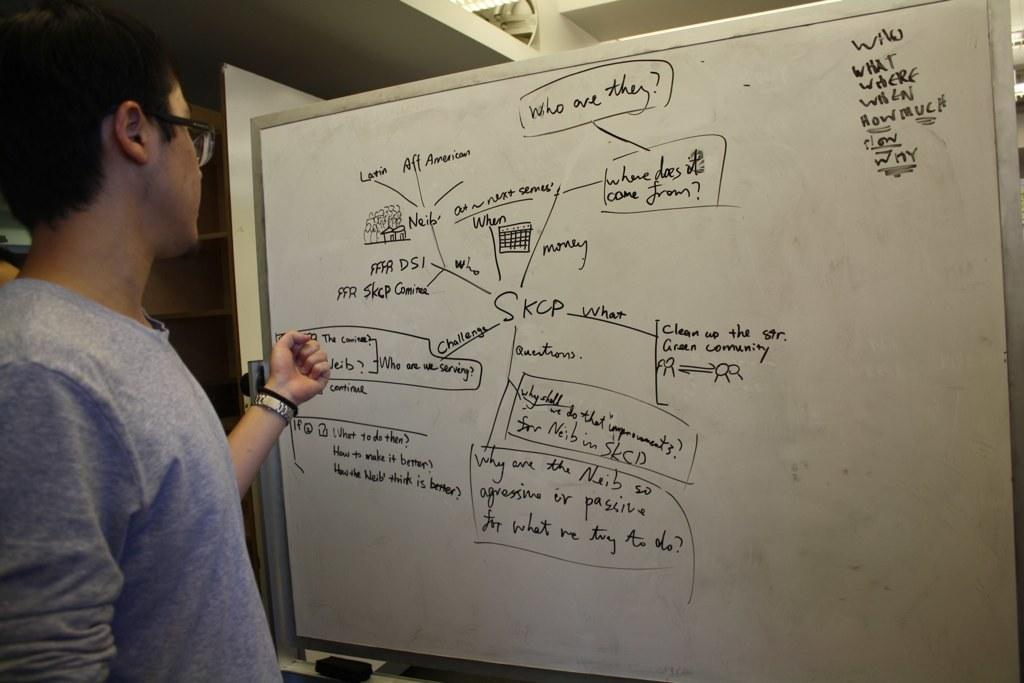Provide a one-sentence caption for the provided image. A man stands in front of a white board with a diagram that stems out from the word "SKCP" in the middle. 